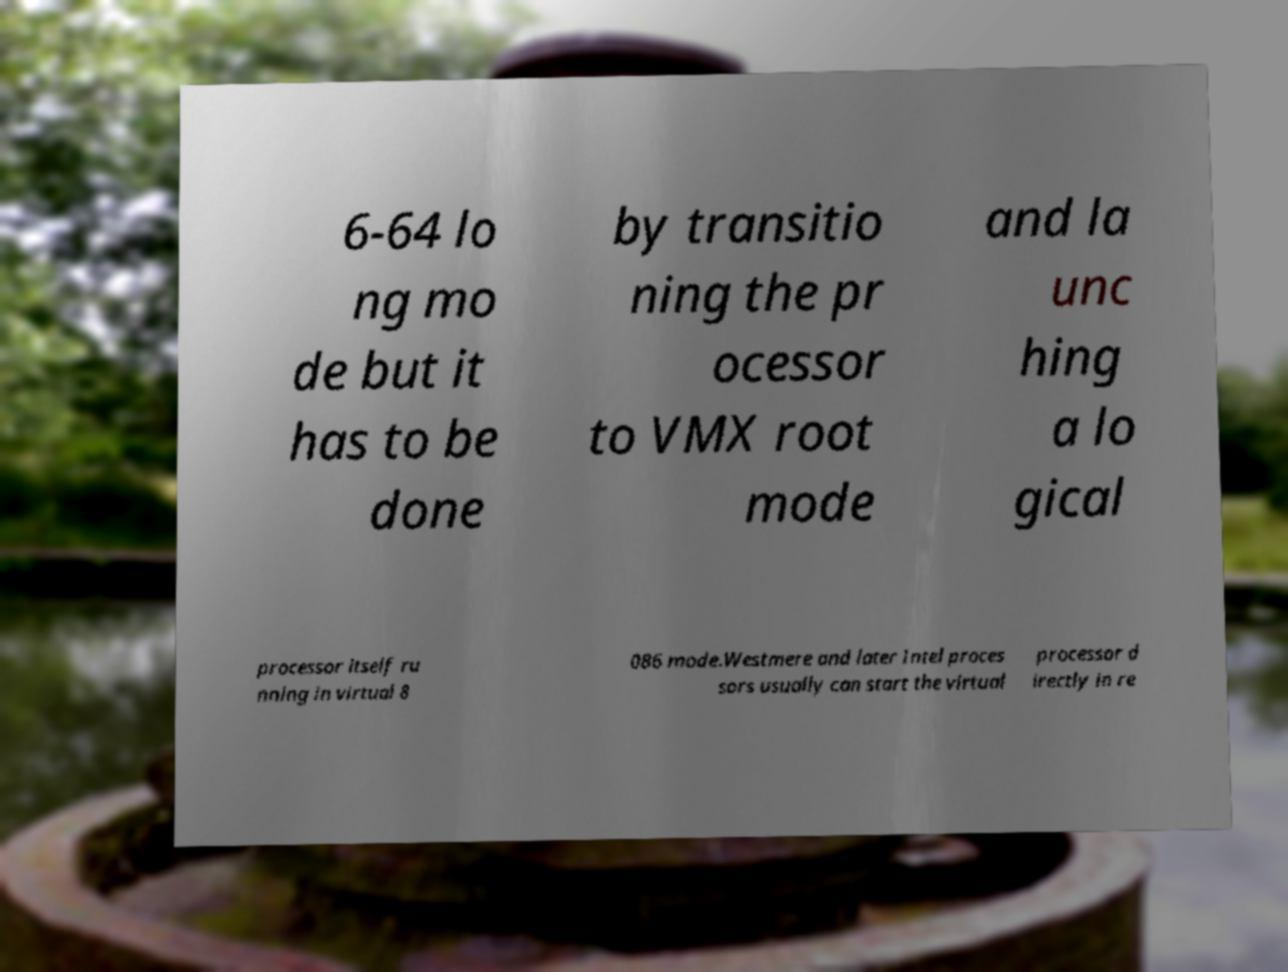Could you assist in decoding the text presented in this image and type it out clearly? 6-64 lo ng mo de but it has to be done by transitio ning the pr ocessor to VMX root mode and la unc hing a lo gical processor itself ru nning in virtual 8 086 mode.Westmere and later Intel proces sors usually can start the virtual processor d irectly in re 